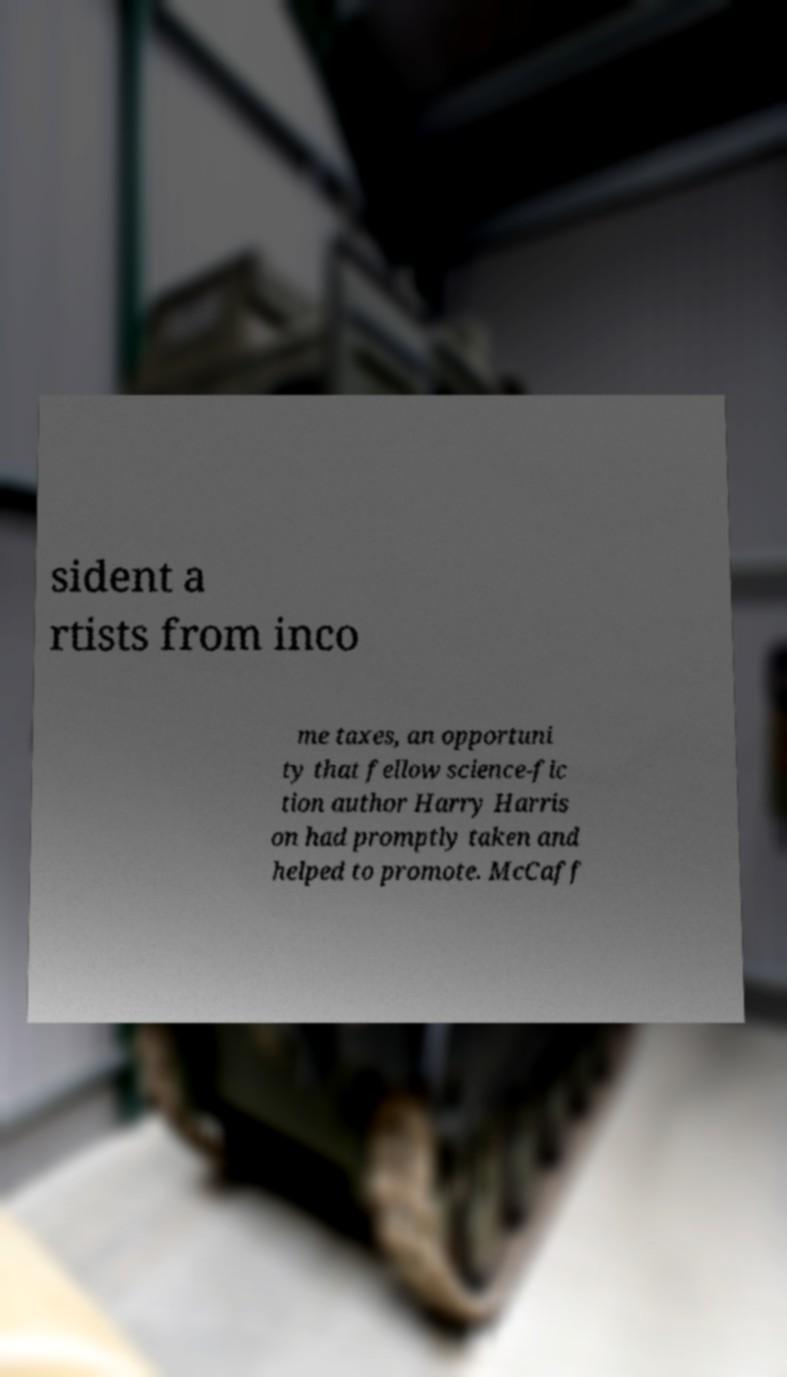Can you read and provide the text displayed in the image?This photo seems to have some interesting text. Can you extract and type it out for me? sident a rtists from inco me taxes, an opportuni ty that fellow science-fic tion author Harry Harris on had promptly taken and helped to promote. McCaff 